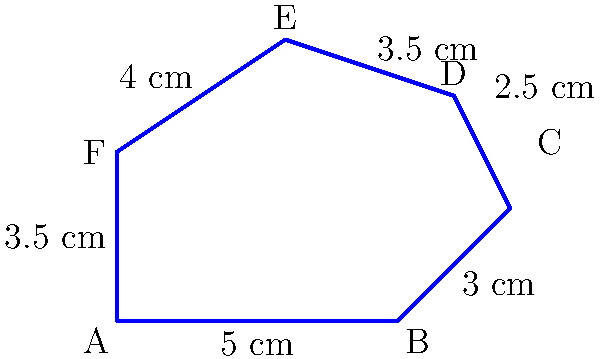You're creating a felt cutout for a stuffed animal project with your grandchildren. The shape of the cutout is irregular, as shown in the diagram. Calculate the perimeter of this felt piece to determine how much decorative ribbon you'll need to edge the entire shape. Round your answer to the nearest centimeter. To calculate the perimeter of the irregular shape, we need to sum up the lengths of all sides:

1. Side AB = 5 cm
2. Side BC = 3 cm
3. Side CD = 2.5 cm
4. Side DE = 3.5 cm
5. Side EF = 4 cm
6. Side FA = 3.5 cm

Now, let's add all these lengths:

$$\text{Perimeter} = 5 + 3 + 2.5 + 3.5 + 4 + 3.5 = 21.5 \text{ cm}$$

Rounding to the nearest centimeter:
$$21.5 \text{ cm} \approx 22 \text{ cm}$$

Therefore, you'll need approximately 22 cm of decorative ribbon to edge the entire felt cutout.
Answer: 22 cm 